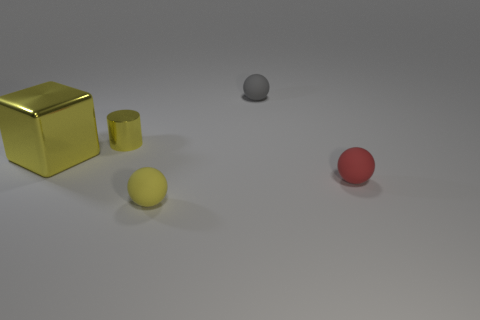Subtract all small gray balls. How many balls are left? 2 Add 1 tiny gray cylinders. How many objects exist? 6 Subtract all balls. How many objects are left? 2 Subtract all big yellow blocks. Subtract all cylinders. How many objects are left? 3 Add 3 big yellow objects. How many big yellow objects are left? 4 Add 3 large blue metal spheres. How many large blue metal spheres exist? 3 Subtract 0 cyan cubes. How many objects are left? 5 Subtract all gray cylinders. Subtract all yellow cubes. How many cylinders are left? 1 